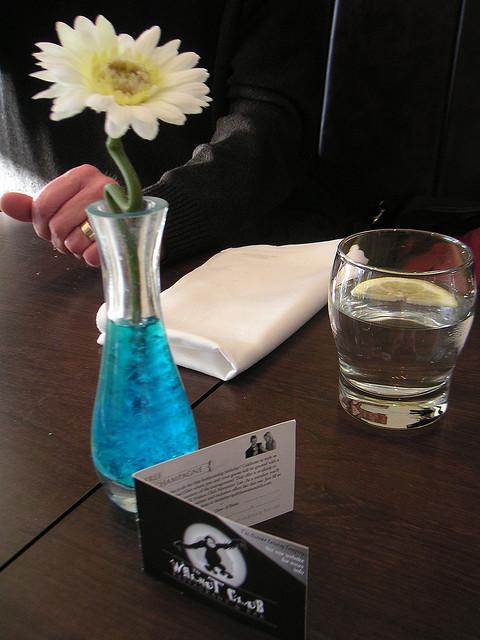Does the flower need water?
Be succinct. No. Is that flower vase a drink, or a decoration?
Short answer required. Decoration. Is that flower real or fake?
Write a very short answer. Fake. What color is the water in the vase?
Quick response, please. Blue. Is that a man or woman in the background?
Concise answer only. Woman. Is the one that has something in it water or wine?
Quick response, please. Water. 